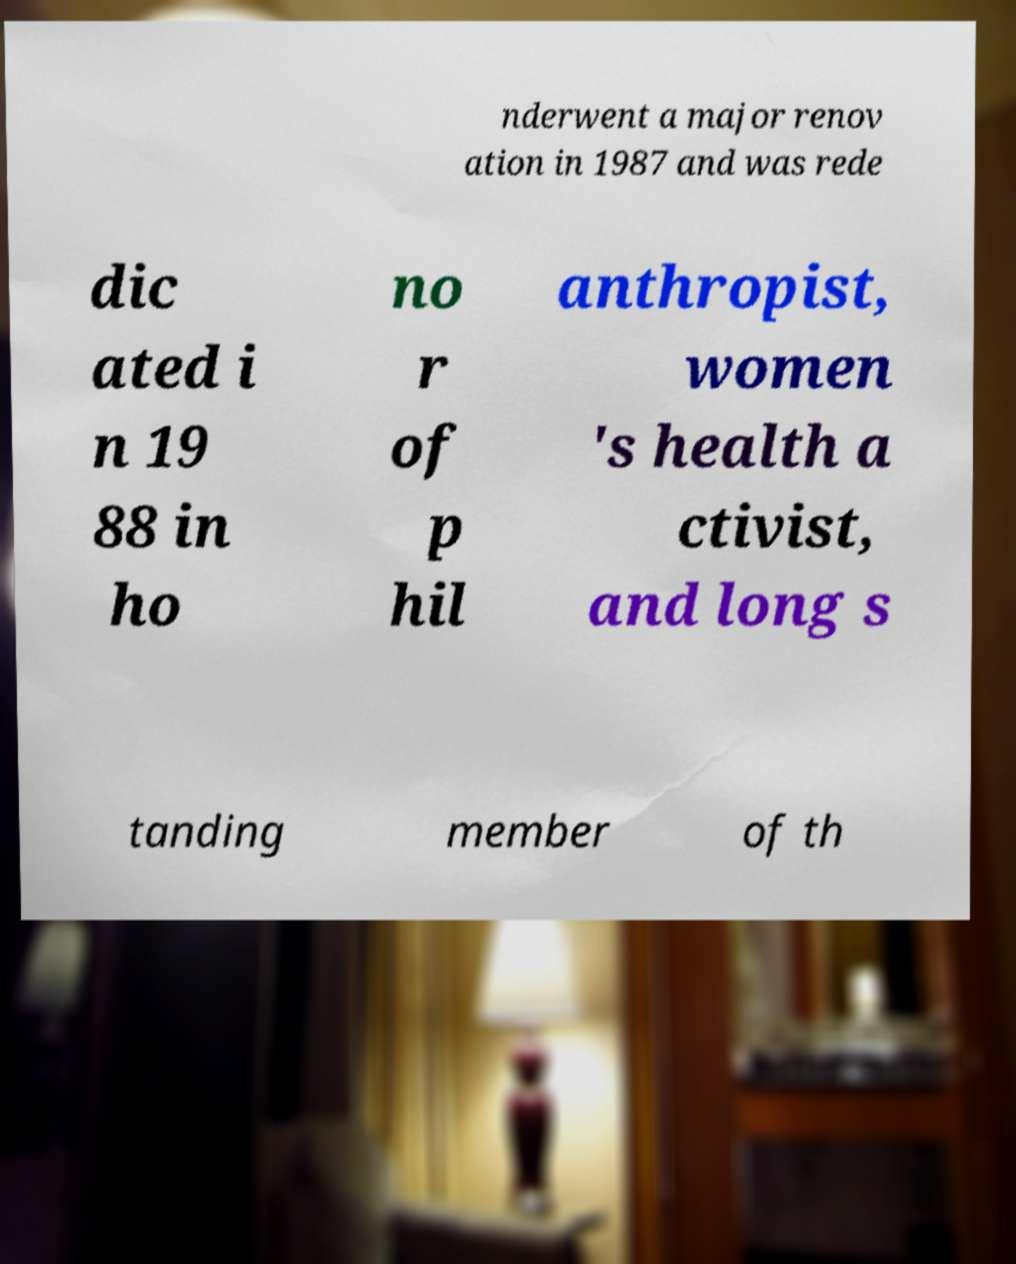There's text embedded in this image that I need extracted. Can you transcribe it verbatim? nderwent a major renov ation in 1987 and was rede dic ated i n 19 88 in ho no r of p hil anthropist, women 's health a ctivist, and long s tanding member of th 